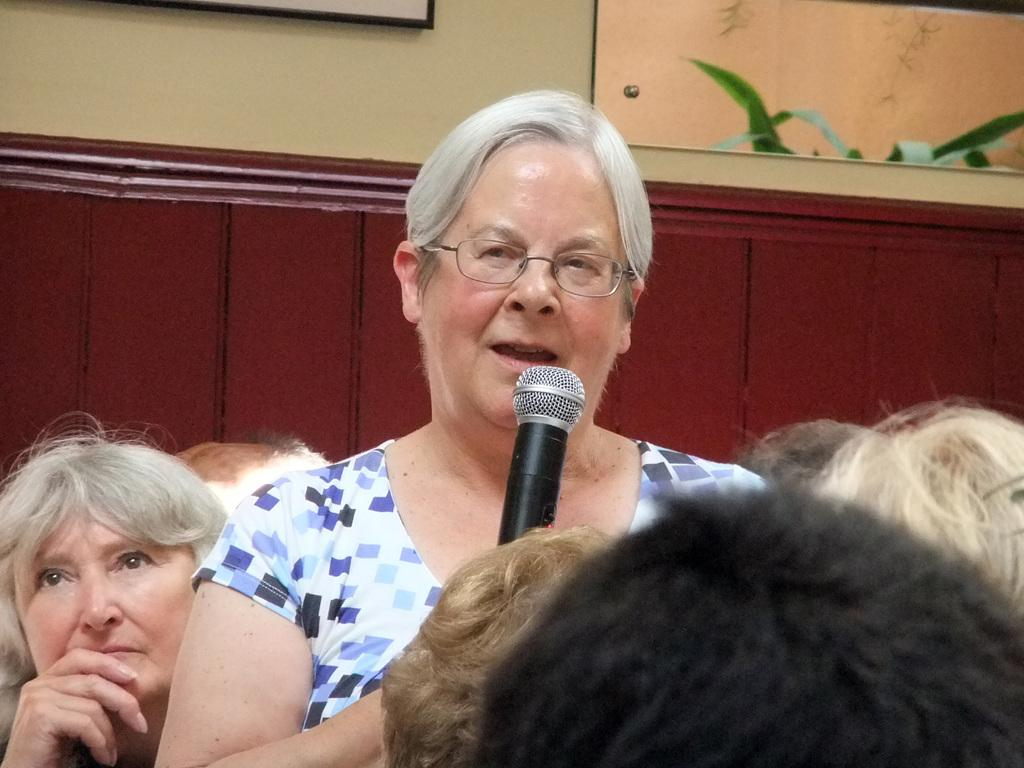Who is the main subject in the image? There is a woman in the image. What is the woman doing in the image? The woman is standing and speaking with the help of a microphone. Can you describe the audience in the image? There are people seated around the woman. What decorative elements can be seen in the image? There is a photo frame on the wall and a plant on the side. What type of pets are visible in the image? There are no pets visible in the image. What library is the woman speaking in? The image does not indicate that the woman is in a library. 